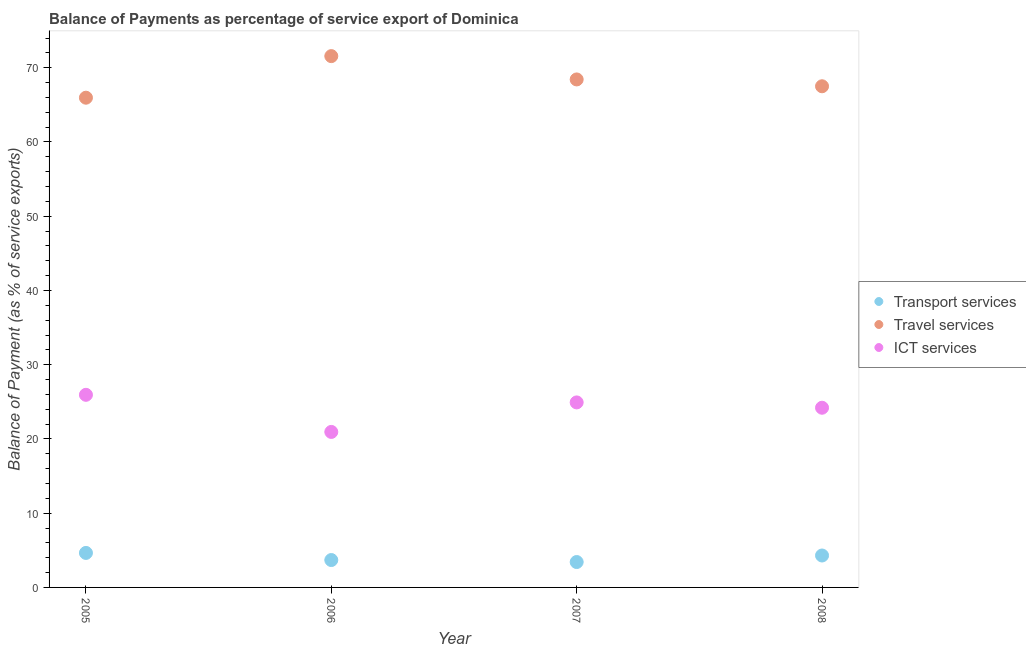Is the number of dotlines equal to the number of legend labels?
Your answer should be compact. Yes. What is the balance of payment of ict services in 2008?
Your answer should be compact. 24.2. Across all years, what is the maximum balance of payment of transport services?
Offer a very short reply. 4.65. Across all years, what is the minimum balance of payment of transport services?
Offer a terse response. 3.42. In which year was the balance of payment of travel services maximum?
Your answer should be very brief. 2006. What is the total balance of payment of transport services in the graph?
Ensure brevity in your answer.  16.06. What is the difference between the balance of payment of travel services in 2006 and that in 2008?
Offer a very short reply. 4.06. What is the difference between the balance of payment of ict services in 2007 and the balance of payment of travel services in 2008?
Ensure brevity in your answer.  -42.58. What is the average balance of payment of transport services per year?
Offer a terse response. 4.01. In the year 2008, what is the difference between the balance of payment of ict services and balance of payment of transport services?
Make the answer very short. 19.9. What is the ratio of the balance of payment of transport services in 2006 to that in 2008?
Make the answer very short. 0.86. Is the balance of payment of ict services in 2006 less than that in 2008?
Your answer should be very brief. Yes. What is the difference between the highest and the second highest balance of payment of transport services?
Give a very brief answer. 0.35. What is the difference between the highest and the lowest balance of payment of travel services?
Your answer should be very brief. 5.6. In how many years, is the balance of payment of transport services greater than the average balance of payment of transport services taken over all years?
Make the answer very short. 2. Is the sum of the balance of payment of ict services in 2005 and 2008 greater than the maximum balance of payment of transport services across all years?
Your answer should be compact. Yes. Does the balance of payment of ict services monotonically increase over the years?
Ensure brevity in your answer.  No. Is the balance of payment of travel services strictly greater than the balance of payment of transport services over the years?
Make the answer very short. Yes. How many dotlines are there?
Provide a succinct answer. 3. How many years are there in the graph?
Provide a short and direct response. 4. Does the graph contain grids?
Offer a very short reply. No. Where does the legend appear in the graph?
Give a very brief answer. Center right. What is the title of the graph?
Make the answer very short. Balance of Payments as percentage of service export of Dominica. What is the label or title of the X-axis?
Your answer should be very brief. Year. What is the label or title of the Y-axis?
Provide a succinct answer. Balance of Payment (as % of service exports). What is the Balance of Payment (as % of service exports) in Transport services in 2005?
Provide a succinct answer. 4.65. What is the Balance of Payment (as % of service exports) in Travel services in 2005?
Keep it short and to the point. 65.97. What is the Balance of Payment (as % of service exports) in ICT services in 2005?
Offer a very short reply. 25.94. What is the Balance of Payment (as % of service exports) of Transport services in 2006?
Keep it short and to the point. 3.69. What is the Balance of Payment (as % of service exports) in Travel services in 2006?
Provide a short and direct response. 71.57. What is the Balance of Payment (as % of service exports) in ICT services in 2006?
Your answer should be very brief. 20.95. What is the Balance of Payment (as % of service exports) of Transport services in 2007?
Offer a terse response. 3.42. What is the Balance of Payment (as % of service exports) in Travel services in 2007?
Your answer should be compact. 68.43. What is the Balance of Payment (as % of service exports) of ICT services in 2007?
Make the answer very short. 24.92. What is the Balance of Payment (as % of service exports) in Transport services in 2008?
Provide a short and direct response. 4.3. What is the Balance of Payment (as % of service exports) of Travel services in 2008?
Provide a short and direct response. 67.51. What is the Balance of Payment (as % of service exports) in ICT services in 2008?
Your response must be concise. 24.2. Across all years, what is the maximum Balance of Payment (as % of service exports) of Transport services?
Your response must be concise. 4.65. Across all years, what is the maximum Balance of Payment (as % of service exports) of Travel services?
Make the answer very short. 71.57. Across all years, what is the maximum Balance of Payment (as % of service exports) in ICT services?
Provide a succinct answer. 25.94. Across all years, what is the minimum Balance of Payment (as % of service exports) in Transport services?
Offer a very short reply. 3.42. Across all years, what is the minimum Balance of Payment (as % of service exports) in Travel services?
Your answer should be compact. 65.97. Across all years, what is the minimum Balance of Payment (as % of service exports) of ICT services?
Ensure brevity in your answer.  20.95. What is the total Balance of Payment (as % of service exports) in Transport services in the graph?
Your answer should be very brief. 16.06. What is the total Balance of Payment (as % of service exports) of Travel services in the graph?
Ensure brevity in your answer.  273.46. What is the total Balance of Payment (as % of service exports) in ICT services in the graph?
Offer a very short reply. 96.02. What is the difference between the Balance of Payment (as % of service exports) in Travel services in 2005 and that in 2006?
Make the answer very short. -5.6. What is the difference between the Balance of Payment (as % of service exports) in ICT services in 2005 and that in 2006?
Make the answer very short. 5. What is the difference between the Balance of Payment (as % of service exports) in Transport services in 2005 and that in 2007?
Offer a very short reply. 1.23. What is the difference between the Balance of Payment (as % of service exports) of Travel services in 2005 and that in 2007?
Give a very brief answer. -2.46. What is the difference between the Balance of Payment (as % of service exports) in ICT services in 2005 and that in 2007?
Give a very brief answer. 1.02. What is the difference between the Balance of Payment (as % of service exports) in Transport services in 2005 and that in 2008?
Your answer should be compact. 0.35. What is the difference between the Balance of Payment (as % of service exports) in Travel services in 2005 and that in 2008?
Offer a terse response. -1.54. What is the difference between the Balance of Payment (as % of service exports) of ICT services in 2005 and that in 2008?
Provide a succinct answer. 1.74. What is the difference between the Balance of Payment (as % of service exports) of Transport services in 2006 and that in 2007?
Ensure brevity in your answer.  0.27. What is the difference between the Balance of Payment (as % of service exports) of Travel services in 2006 and that in 2007?
Give a very brief answer. 3.14. What is the difference between the Balance of Payment (as % of service exports) of ICT services in 2006 and that in 2007?
Provide a succinct answer. -3.98. What is the difference between the Balance of Payment (as % of service exports) in Transport services in 2006 and that in 2008?
Offer a very short reply. -0.61. What is the difference between the Balance of Payment (as % of service exports) of Travel services in 2006 and that in 2008?
Keep it short and to the point. 4.06. What is the difference between the Balance of Payment (as % of service exports) in ICT services in 2006 and that in 2008?
Provide a short and direct response. -3.26. What is the difference between the Balance of Payment (as % of service exports) of Transport services in 2007 and that in 2008?
Your answer should be compact. -0.88. What is the difference between the Balance of Payment (as % of service exports) of Travel services in 2007 and that in 2008?
Keep it short and to the point. 0.92. What is the difference between the Balance of Payment (as % of service exports) of ICT services in 2007 and that in 2008?
Offer a terse response. 0.72. What is the difference between the Balance of Payment (as % of service exports) of Transport services in 2005 and the Balance of Payment (as % of service exports) of Travel services in 2006?
Offer a very short reply. -66.92. What is the difference between the Balance of Payment (as % of service exports) of Transport services in 2005 and the Balance of Payment (as % of service exports) of ICT services in 2006?
Give a very brief answer. -16.3. What is the difference between the Balance of Payment (as % of service exports) of Travel services in 2005 and the Balance of Payment (as % of service exports) of ICT services in 2006?
Keep it short and to the point. 45.02. What is the difference between the Balance of Payment (as % of service exports) of Transport services in 2005 and the Balance of Payment (as % of service exports) of Travel services in 2007?
Your answer should be compact. -63.78. What is the difference between the Balance of Payment (as % of service exports) of Transport services in 2005 and the Balance of Payment (as % of service exports) of ICT services in 2007?
Give a very brief answer. -20.27. What is the difference between the Balance of Payment (as % of service exports) of Travel services in 2005 and the Balance of Payment (as % of service exports) of ICT services in 2007?
Offer a very short reply. 41.04. What is the difference between the Balance of Payment (as % of service exports) in Transport services in 2005 and the Balance of Payment (as % of service exports) in Travel services in 2008?
Provide a succinct answer. -62.86. What is the difference between the Balance of Payment (as % of service exports) of Transport services in 2005 and the Balance of Payment (as % of service exports) of ICT services in 2008?
Your answer should be compact. -19.56. What is the difference between the Balance of Payment (as % of service exports) in Travel services in 2005 and the Balance of Payment (as % of service exports) in ICT services in 2008?
Offer a very short reply. 41.76. What is the difference between the Balance of Payment (as % of service exports) of Transport services in 2006 and the Balance of Payment (as % of service exports) of Travel services in 2007?
Offer a very short reply. -64.74. What is the difference between the Balance of Payment (as % of service exports) in Transport services in 2006 and the Balance of Payment (as % of service exports) in ICT services in 2007?
Provide a short and direct response. -21.23. What is the difference between the Balance of Payment (as % of service exports) in Travel services in 2006 and the Balance of Payment (as % of service exports) in ICT services in 2007?
Ensure brevity in your answer.  46.64. What is the difference between the Balance of Payment (as % of service exports) of Transport services in 2006 and the Balance of Payment (as % of service exports) of Travel services in 2008?
Ensure brevity in your answer.  -63.82. What is the difference between the Balance of Payment (as % of service exports) in Transport services in 2006 and the Balance of Payment (as % of service exports) in ICT services in 2008?
Offer a terse response. -20.51. What is the difference between the Balance of Payment (as % of service exports) of Travel services in 2006 and the Balance of Payment (as % of service exports) of ICT services in 2008?
Your answer should be compact. 47.36. What is the difference between the Balance of Payment (as % of service exports) of Transport services in 2007 and the Balance of Payment (as % of service exports) of Travel services in 2008?
Provide a short and direct response. -64.09. What is the difference between the Balance of Payment (as % of service exports) in Transport services in 2007 and the Balance of Payment (as % of service exports) in ICT services in 2008?
Ensure brevity in your answer.  -20.78. What is the difference between the Balance of Payment (as % of service exports) in Travel services in 2007 and the Balance of Payment (as % of service exports) in ICT services in 2008?
Your answer should be very brief. 44.22. What is the average Balance of Payment (as % of service exports) in Transport services per year?
Provide a short and direct response. 4.01. What is the average Balance of Payment (as % of service exports) in Travel services per year?
Your answer should be very brief. 68.37. What is the average Balance of Payment (as % of service exports) of ICT services per year?
Give a very brief answer. 24. In the year 2005, what is the difference between the Balance of Payment (as % of service exports) of Transport services and Balance of Payment (as % of service exports) of Travel services?
Your response must be concise. -61.32. In the year 2005, what is the difference between the Balance of Payment (as % of service exports) of Transport services and Balance of Payment (as % of service exports) of ICT services?
Make the answer very short. -21.3. In the year 2005, what is the difference between the Balance of Payment (as % of service exports) in Travel services and Balance of Payment (as % of service exports) in ICT services?
Ensure brevity in your answer.  40.02. In the year 2006, what is the difference between the Balance of Payment (as % of service exports) in Transport services and Balance of Payment (as % of service exports) in Travel services?
Make the answer very short. -67.88. In the year 2006, what is the difference between the Balance of Payment (as % of service exports) in Transport services and Balance of Payment (as % of service exports) in ICT services?
Your response must be concise. -17.26. In the year 2006, what is the difference between the Balance of Payment (as % of service exports) in Travel services and Balance of Payment (as % of service exports) in ICT services?
Provide a short and direct response. 50.62. In the year 2007, what is the difference between the Balance of Payment (as % of service exports) in Transport services and Balance of Payment (as % of service exports) in Travel services?
Give a very brief answer. -65.01. In the year 2007, what is the difference between the Balance of Payment (as % of service exports) of Transport services and Balance of Payment (as % of service exports) of ICT services?
Your response must be concise. -21.5. In the year 2007, what is the difference between the Balance of Payment (as % of service exports) of Travel services and Balance of Payment (as % of service exports) of ICT services?
Make the answer very short. 43.5. In the year 2008, what is the difference between the Balance of Payment (as % of service exports) in Transport services and Balance of Payment (as % of service exports) in Travel services?
Your answer should be very brief. -63.21. In the year 2008, what is the difference between the Balance of Payment (as % of service exports) in Transport services and Balance of Payment (as % of service exports) in ICT services?
Your answer should be compact. -19.9. In the year 2008, what is the difference between the Balance of Payment (as % of service exports) of Travel services and Balance of Payment (as % of service exports) of ICT services?
Give a very brief answer. 43.3. What is the ratio of the Balance of Payment (as % of service exports) of Transport services in 2005 to that in 2006?
Give a very brief answer. 1.26. What is the ratio of the Balance of Payment (as % of service exports) in Travel services in 2005 to that in 2006?
Offer a terse response. 0.92. What is the ratio of the Balance of Payment (as % of service exports) in ICT services in 2005 to that in 2006?
Provide a short and direct response. 1.24. What is the ratio of the Balance of Payment (as % of service exports) of Transport services in 2005 to that in 2007?
Offer a terse response. 1.36. What is the ratio of the Balance of Payment (as % of service exports) in Travel services in 2005 to that in 2007?
Provide a short and direct response. 0.96. What is the ratio of the Balance of Payment (as % of service exports) of ICT services in 2005 to that in 2007?
Offer a very short reply. 1.04. What is the ratio of the Balance of Payment (as % of service exports) of Transport services in 2005 to that in 2008?
Keep it short and to the point. 1.08. What is the ratio of the Balance of Payment (as % of service exports) in Travel services in 2005 to that in 2008?
Your answer should be compact. 0.98. What is the ratio of the Balance of Payment (as % of service exports) in ICT services in 2005 to that in 2008?
Your answer should be compact. 1.07. What is the ratio of the Balance of Payment (as % of service exports) of Transport services in 2006 to that in 2007?
Offer a very short reply. 1.08. What is the ratio of the Balance of Payment (as % of service exports) of Travel services in 2006 to that in 2007?
Your response must be concise. 1.05. What is the ratio of the Balance of Payment (as % of service exports) in ICT services in 2006 to that in 2007?
Your response must be concise. 0.84. What is the ratio of the Balance of Payment (as % of service exports) in Transport services in 2006 to that in 2008?
Offer a terse response. 0.86. What is the ratio of the Balance of Payment (as % of service exports) of Travel services in 2006 to that in 2008?
Give a very brief answer. 1.06. What is the ratio of the Balance of Payment (as % of service exports) in ICT services in 2006 to that in 2008?
Your answer should be compact. 0.87. What is the ratio of the Balance of Payment (as % of service exports) in Transport services in 2007 to that in 2008?
Your response must be concise. 0.8. What is the ratio of the Balance of Payment (as % of service exports) of Travel services in 2007 to that in 2008?
Your answer should be very brief. 1.01. What is the ratio of the Balance of Payment (as % of service exports) in ICT services in 2007 to that in 2008?
Provide a short and direct response. 1.03. What is the difference between the highest and the second highest Balance of Payment (as % of service exports) in Transport services?
Make the answer very short. 0.35. What is the difference between the highest and the second highest Balance of Payment (as % of service exports) of Travel services?
Give a very brief answer. 3.14. What is the difference between the highest and the second highest Balance of Payment (as % of service exports) of ICT services?
Ensure brevity in your answer.  1.02. What is the difference between the highest and the lowest Balance of Payment (as % of service exports) in Transport services?
Provide a short and direct response. 1.23. What is the difference between the highest and the lowest Balance of Payment (as % of service exports) of Travel services?
Provide a succinct answer. 5.6. What is the difference between the highest and the lowest Balance of Payment (as % of service exports) in ICT services?
Provide a short and direct response. 5. 